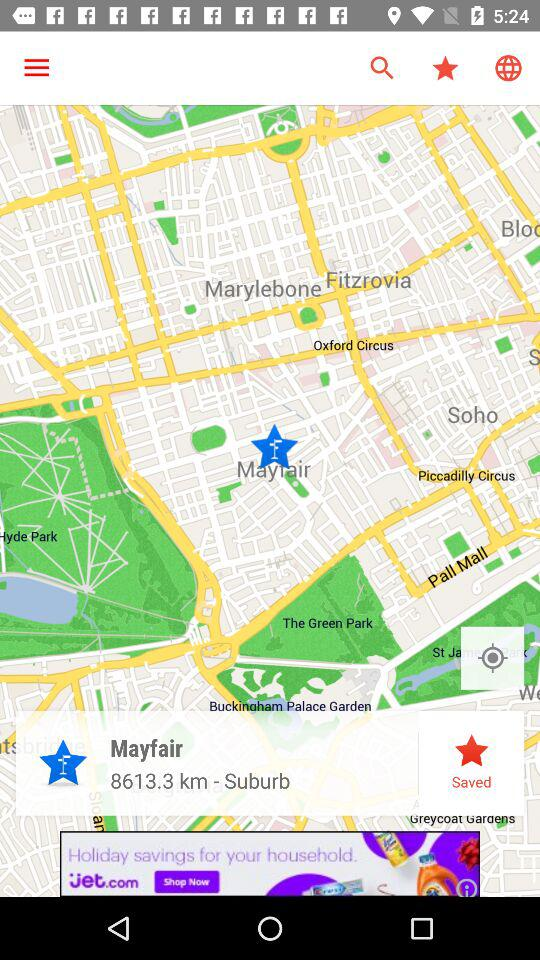What is the distance to Mayfair?
Answer the question using a single word or phrase. 8613.3 km 